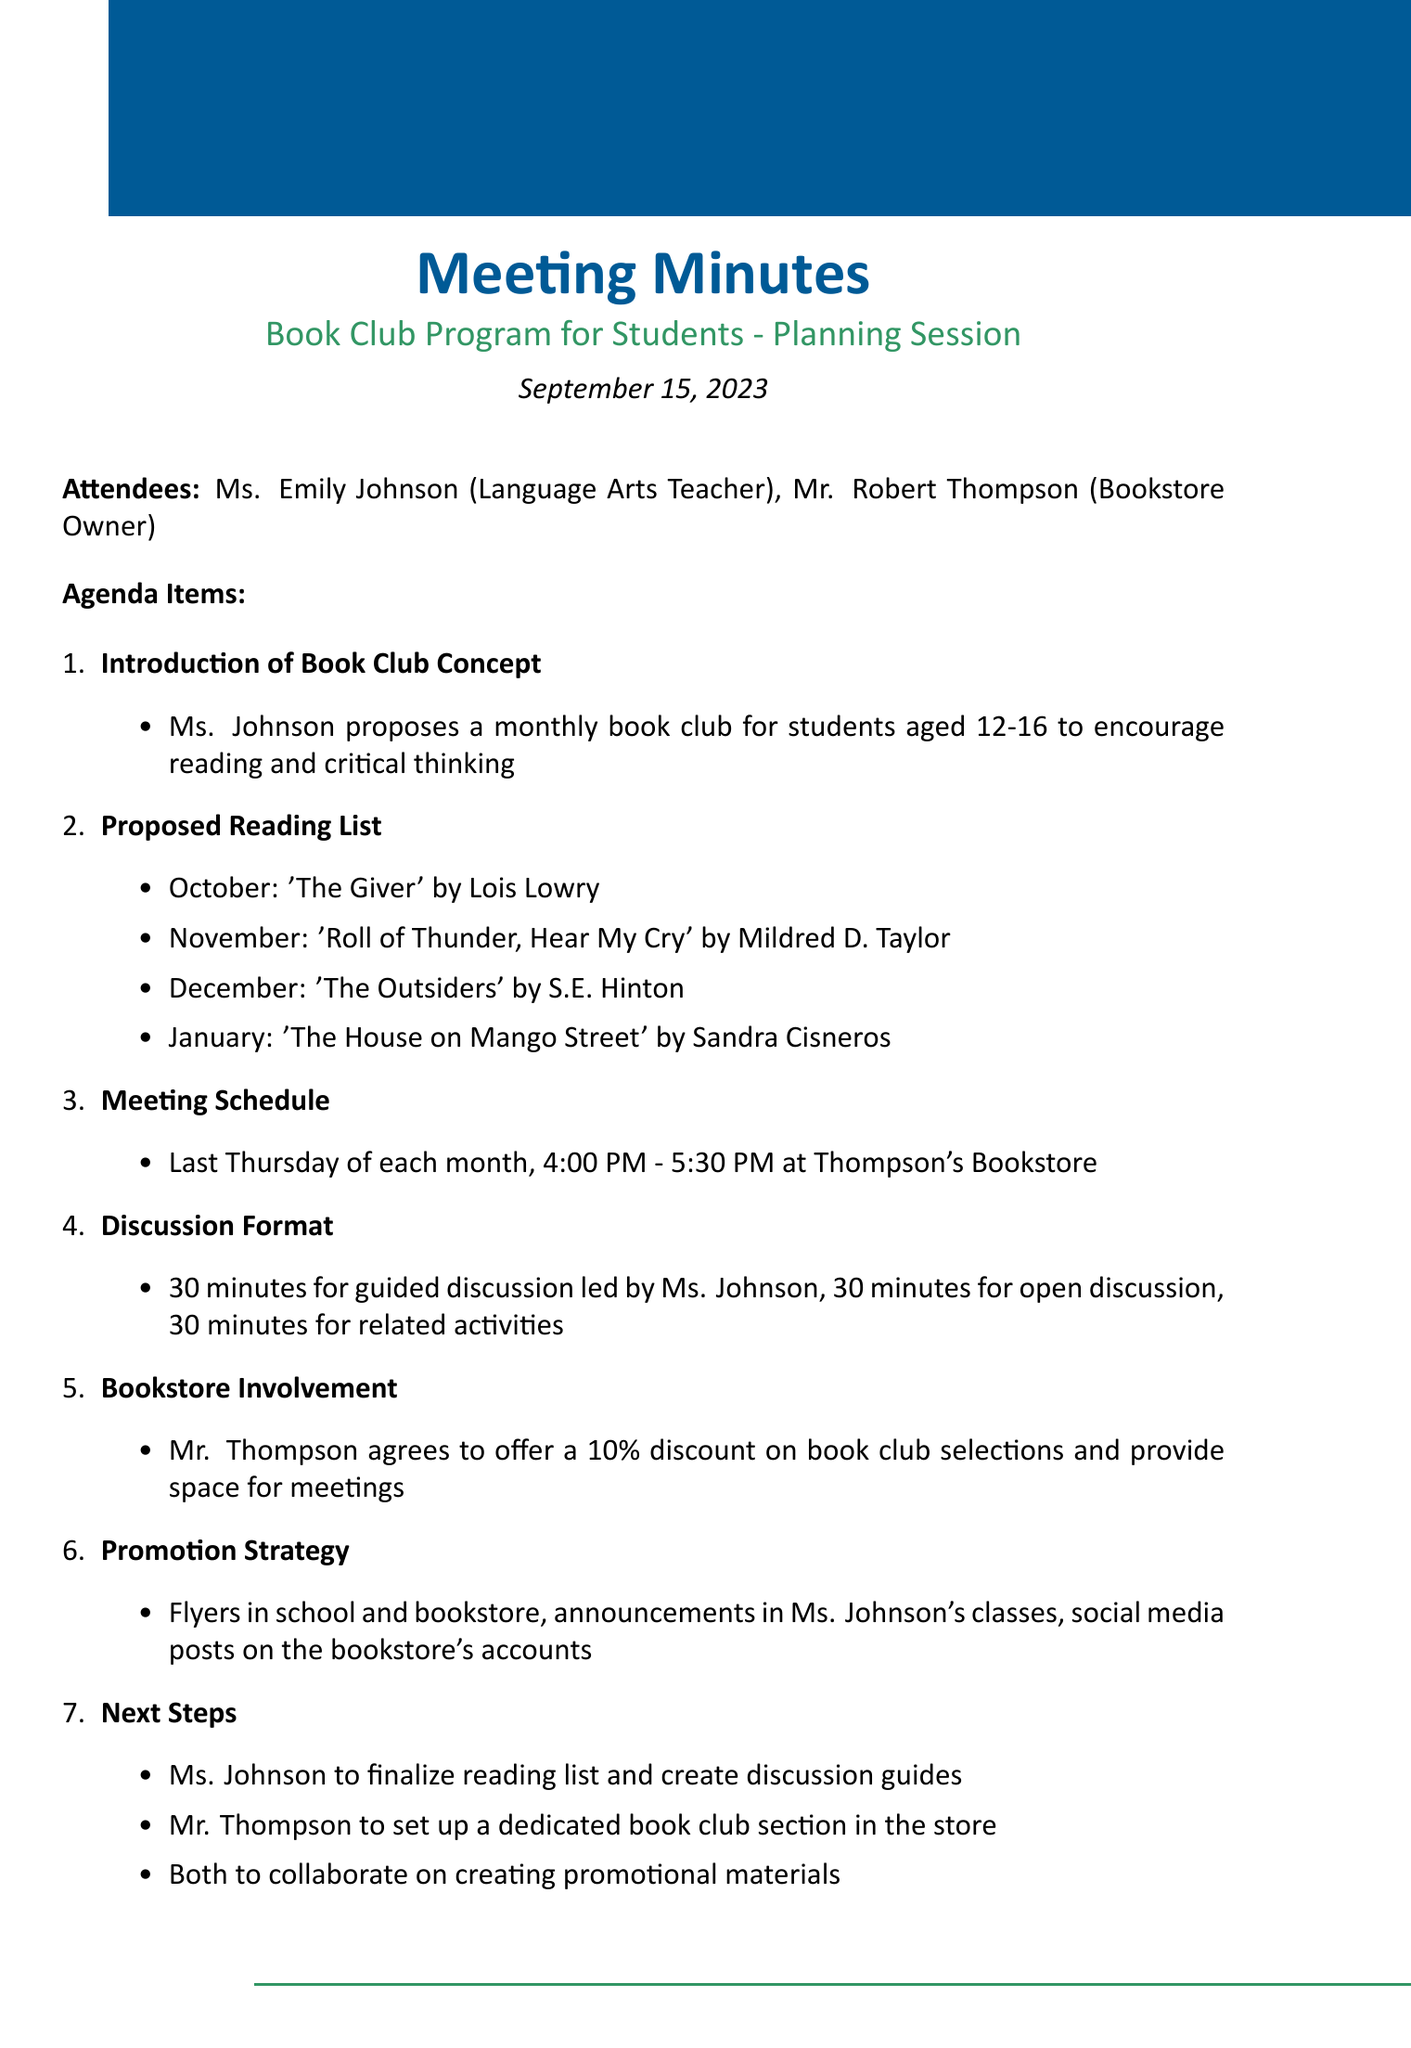What is the title of the meeting? The title of the meeting is stated at the beginning of the document.
Answer: Book Club Program for Students - Planning Session Who is the language arts teacher? Ms. Johnson is identified as the language arts teacher among the attendees.
Answer: Ms. Emily Johnson What month is 'The Giver' scheduled for? The meeting minutes specify 'The Giver' for the month of October in the proposed reading list.
Answer: October What time does the book club meet? The meeting schedule indicates the specific time for the book club meetings.
Answer: 4:00 PM - 5:30 PM What discount will the bookstore owner provide for book club selections? The document mentions a specific discount that Mr. Thompson agrees to offer.
Answer: 10% How many minutes are allocated for guided discussion? The discussion format outlines the time allocated for guided discussion led by Ms. Johnson.
Answer: 30 minutes What is the next step for Ms. Johnson? The next steps outline the responsibilities of each party, specifically what Ms. Johnson will finalize.
Answer: Finalize reading list and create discussion guides What promotional strategy involves social media? The promotion strategy section includes methods for reaching students, specifically involving social media.
Answer: Social media posts on the bookstore's accounts 